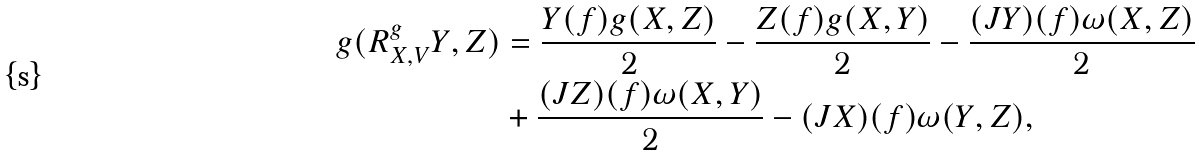<formula> <loc_0><loc_0><loc_500><loc_500>g ( R ^ { g } _ { X , V } Y , Z ) & = \frac { Y ( f ) g ( X , Z ) } { 2 } - \frac { Z ( f ) g ( X , Y ) } { 2 } - \frac { ( J Y ) ( f ) \omega ( X , Z ) } { 2 } \\ & + \frac { ( J Z ) ( f ) \omega ( X , Y ) } { 2 } - ( J X ) ( f ) \omega ( Y , Z ) ,</formula> 